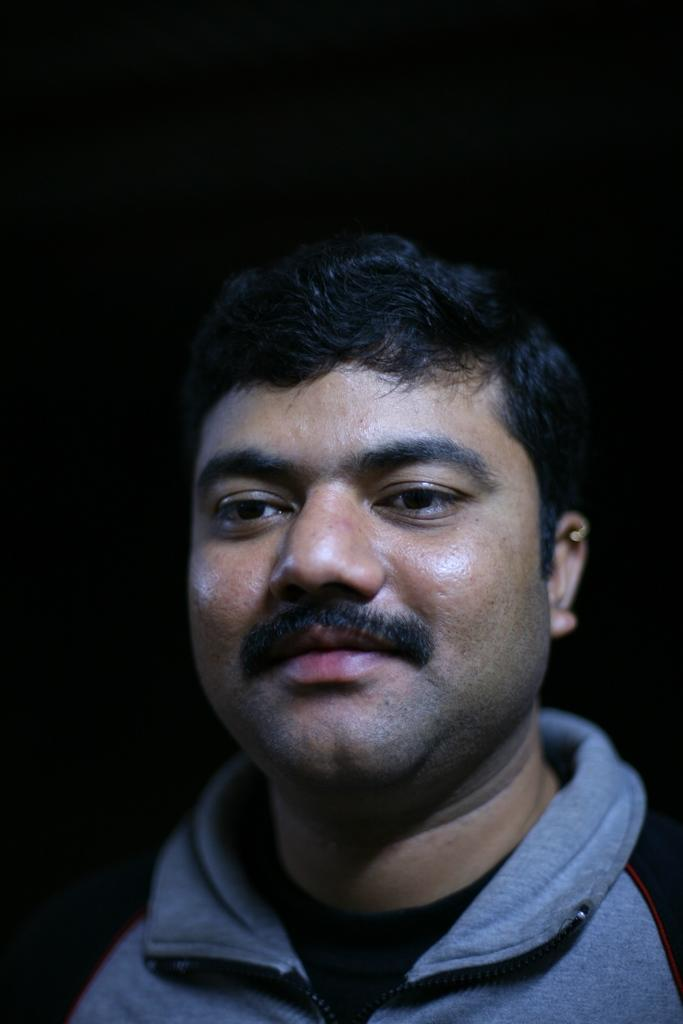Who is present in the image? There is a man in the image. What is the man wearing? The man is wearing a grey t-shirt. What is the man's facial expression? The man is smiling. What can be observed about the background of the image? The background of the image is dark. What type of suit is the boy wearing in the image? There is no boy present in the image, and no suit is visible. 